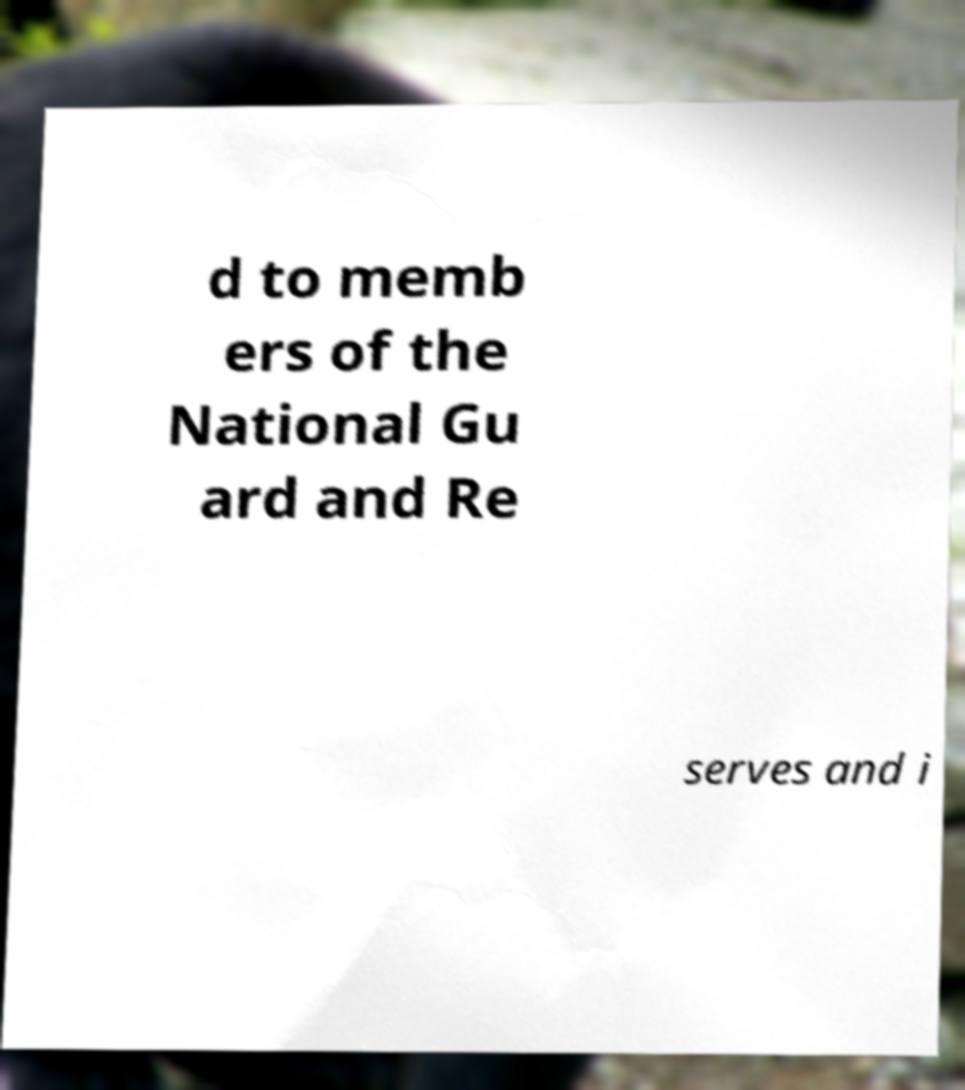Can you accurately transcribe the text from the provided image for me? d to memb ers of the National Gu ard and Re serves and i 